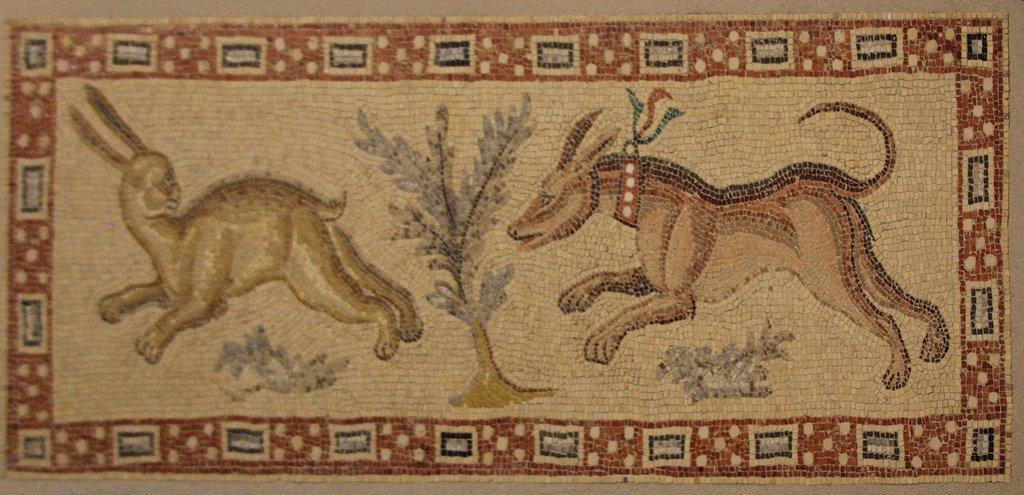Can you describe this image briefly? This image we can see a mat. On the mat there are two animals and one plant. 